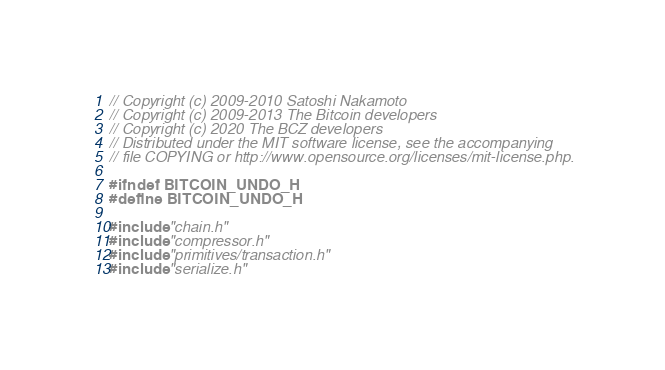Convert code to text. <code><loc_0><loc_0><loc_500><loc_500><_C_>// Copyright (c) 2009-2010 Satoshi Nakamoto
// Copyright (c) 2009-2013 The Bitcoin developers
// Copyright (c) 2020 The BCZ developers
// Distributed under the MIT software license, see the accompanying
// file COPYING or http://www.opensource.org/licenses/mit-license.php.

#ifndef BITCOIN_UNDO_H
#define BITCOIN_UNDO_H

#include "chain.h"
#include "compressor.h"
#include "primitives/transaction.h"
#include "serialize.h"
</code> 